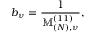Convert formula to latex. <formula><loc_0><loc_0><loc_500><loc_500>b _ { \nu } = \frac { 1 } { \mathbb { M } _ { ( N ) , \nu } ^ { ( 1 1 ) } } ,</formula> 